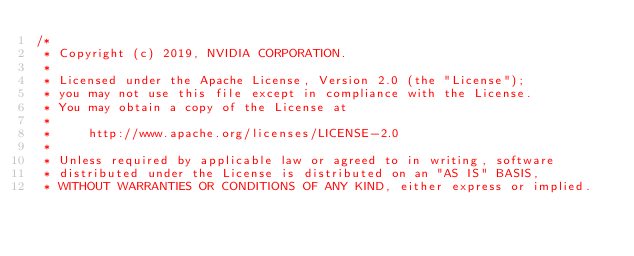Convert code to text. <code><loc_0><loc_0><loc_500><loc_500><_Cuda_>/*
 * Copyright (c) 2019, NVIDIA CORPORATION.
 *
 * Licensed under the Apache License, Version 2.0 (the "License");
 * you may not use this file except in compliance with the License.
 * You may obtain a copy of the License at
 *
 *     http://www.apache.org/licenses/LICENSE-2.0
 *
 * Unless required by applicable law or agreed to in writing, software
 * distributed under the License is distributed on an "AS IS" BASIS,
 * WITHOUT WARRANTIES OR CONDITIONS OF ANY KIND, either express or implied.</code> 